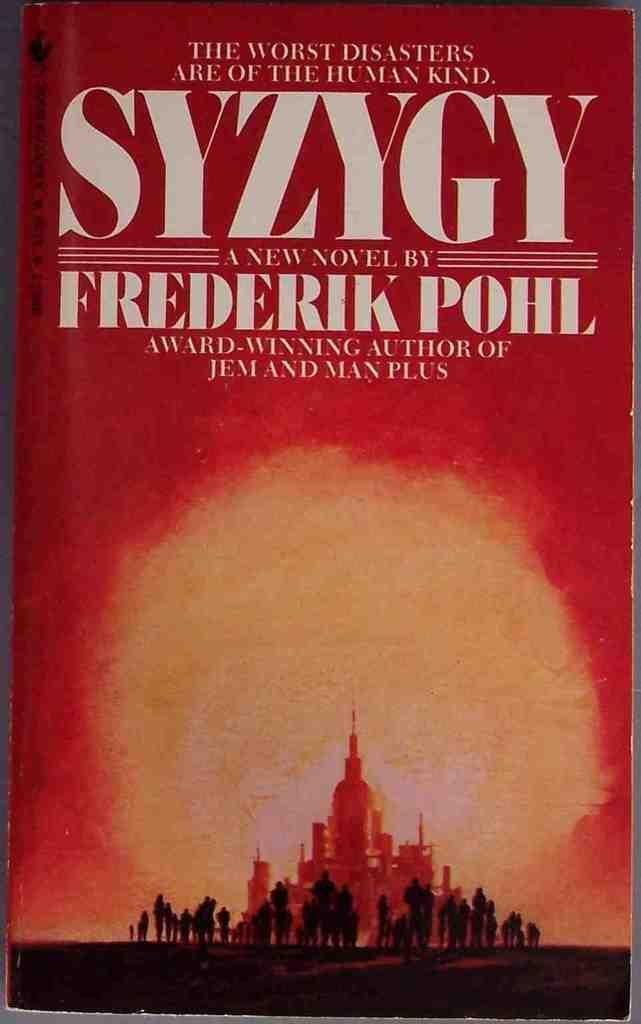<image>
Give a short and clear explanation of the subsequent image. A close up of the novel, SYZYGY, by Frederik Pohl is shown. 